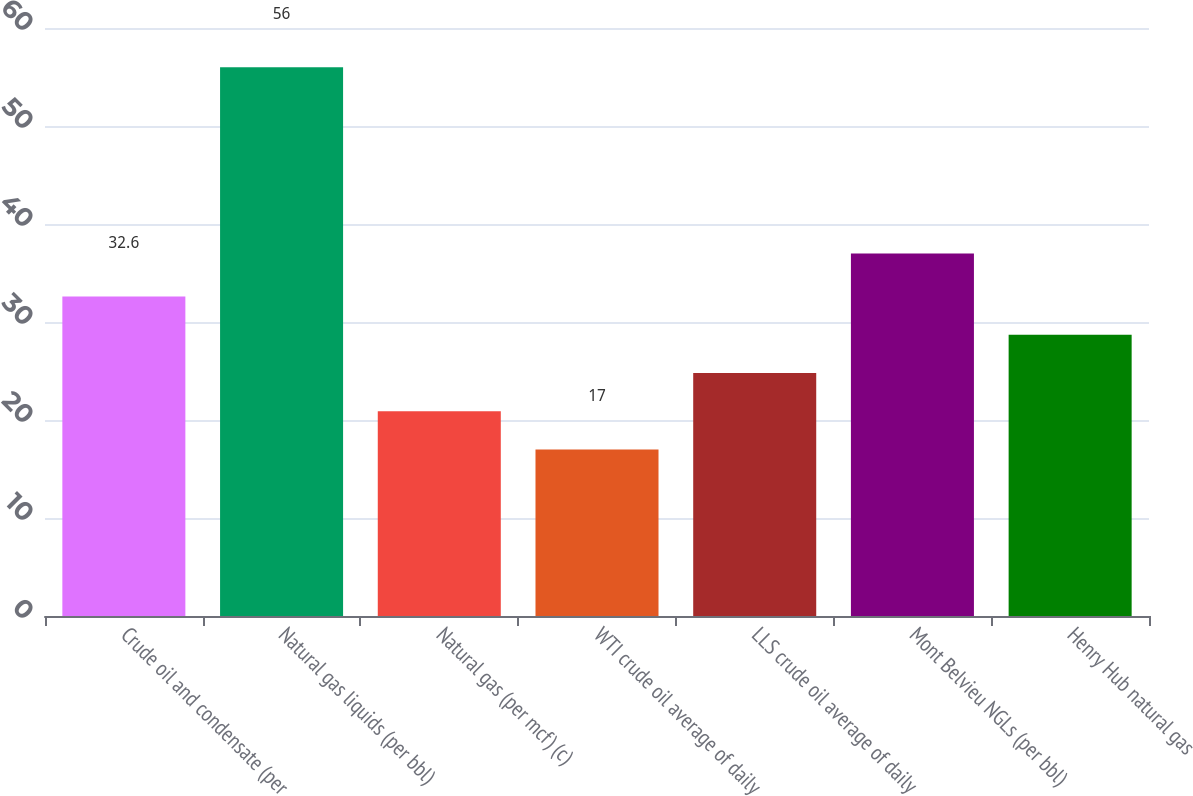Convert chart to OTSL. <chart><loc_0><loc_0><loc_500><loc_500><bar_chart><fcel>Crude oil and condensate (per<fcel>Natural gas liquids (per bbl)<fcel>Natural gas (per mcf) (c)<fcel>WTI crude oil average of daily<fcel>LLS crude oil average of daily<fcel>Mont Belvieu NGLs (per bbl)<fcel>Henry Hub natural gas<nl><fcel>32.6<fcel>56<fcel>20.9<fcel>17<fcel>24.8<fcel>37<fcel>28.7<nl></chart> 